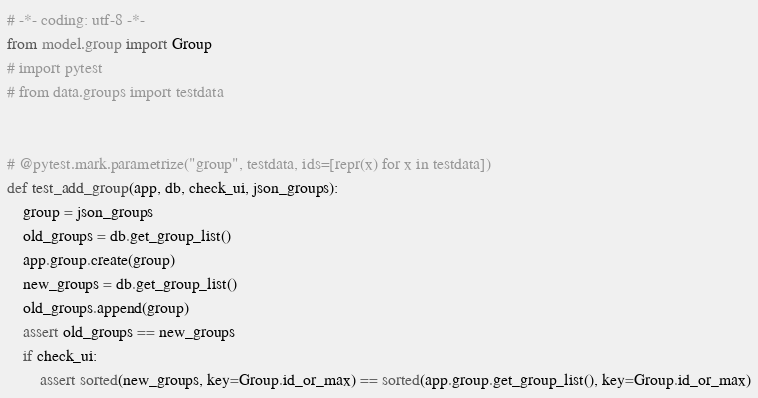<code> <loc_0><loc_0><loc_500><loc_500><_Python_># -*- coding: utf-8 -*-
from model.group import Group
# import pytest
# from data.groups import testdata


# @pytest.mark.parametrize("group", testdata, ids=[repr(x) for x in testdata])
def test_add_group(app, db, check_ui, json_groups):
    group = json_groups
    old_groups = db.get_group_list()
    app.group.create(group)
    new_groups = db.get_group_list()
    old_groups.append(group)
    assert old_groups == new_groups
    if check_ui:
        assert sorted(new_groups, key=Group.id_or_max) == sorted(app.group.get_group_list(), key=Group.id_or_max)
</code> 